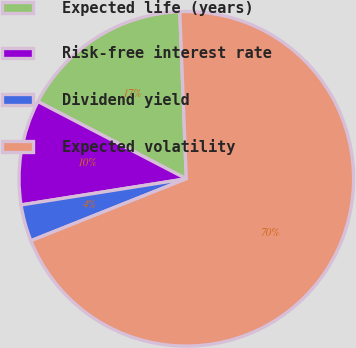Convert chart. <chart><loc_0><loc_0><loc_500><loc_500><pie_chart><fcel>Expected life (years)<fcel>Risk-free interest rate<fcel>Dividend yield<fcel>Expected volatility<nl><fcel>16.74%<fcel>10.14%<fcel>3.54%<fcel>69.58%<nl></chart> 